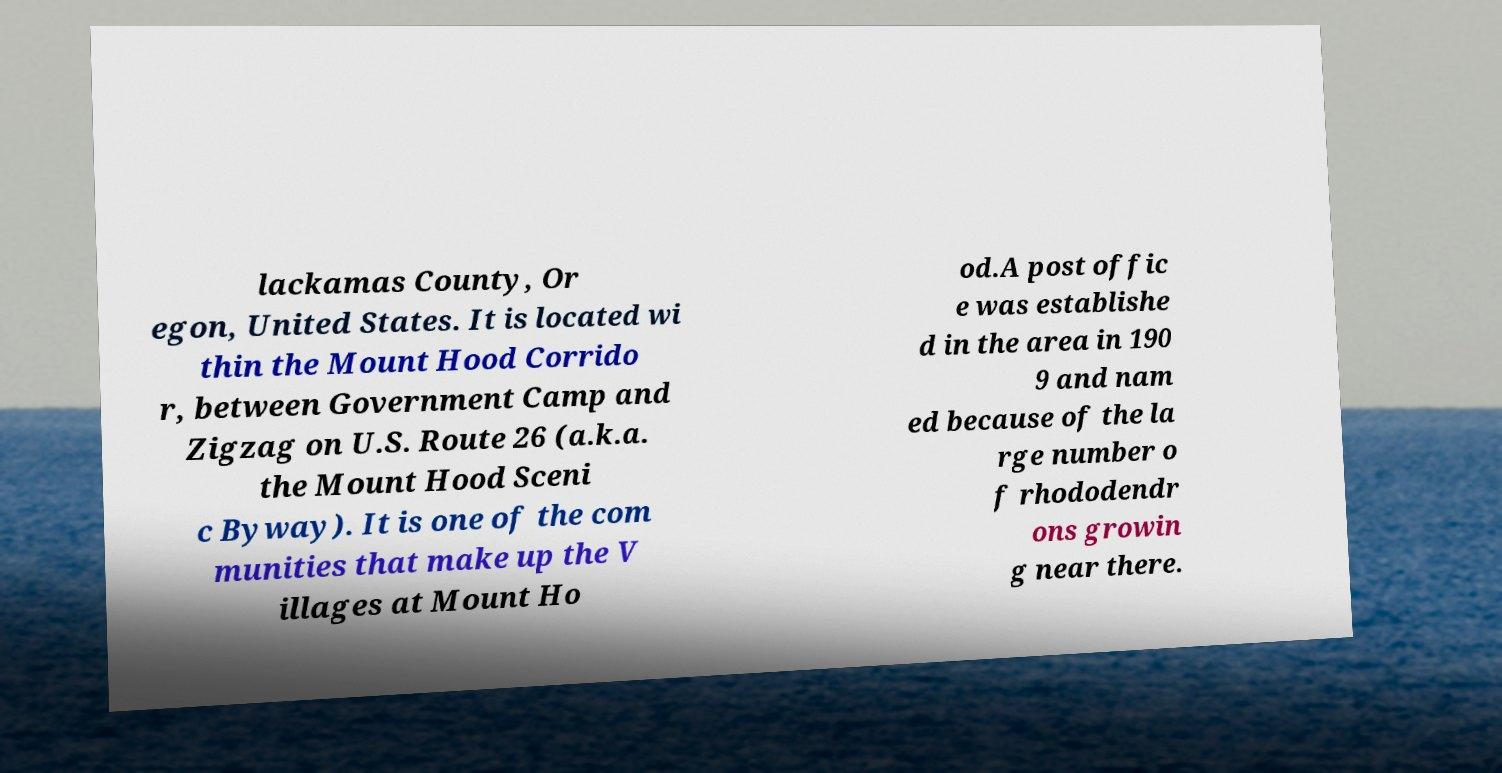Please identify and transcribe the text found in this image. lackamas County, Or egon, United States. It is located wi thin the Mount Hood Corrido r, between Government Camp and Zigzag on U.S. Route 26 (a.k.a. the Mount Hood Sceni c Byway). It is one of the com munities that make up the V illages at Mount Ho od.A post offic e was establishe d in the area in 190 9 and nam ed because of the la rge number o f rhododendr ons growin g near there. 